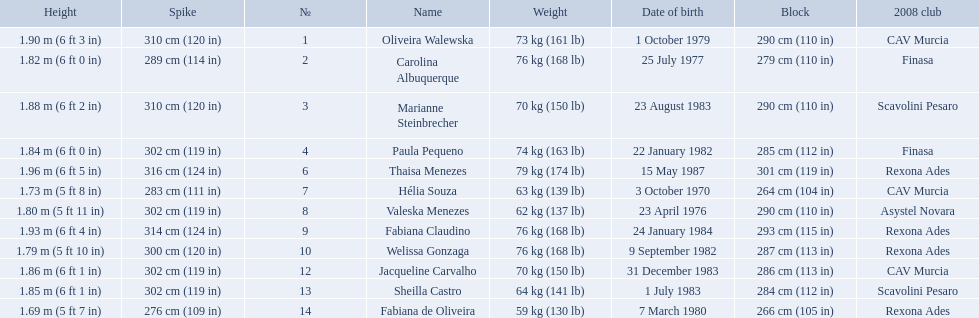How much does fabiana de oliveira weigh? 76 kg (168 lb). How much does helia souza weigh? 63 kg (139 lb). How much does sheilla castro weigh? 64 kg (141 lb). Whose weight did the original question asker incorrectly believe to be the heaviest (they are the second heaviest)? Sheilla Castro. 